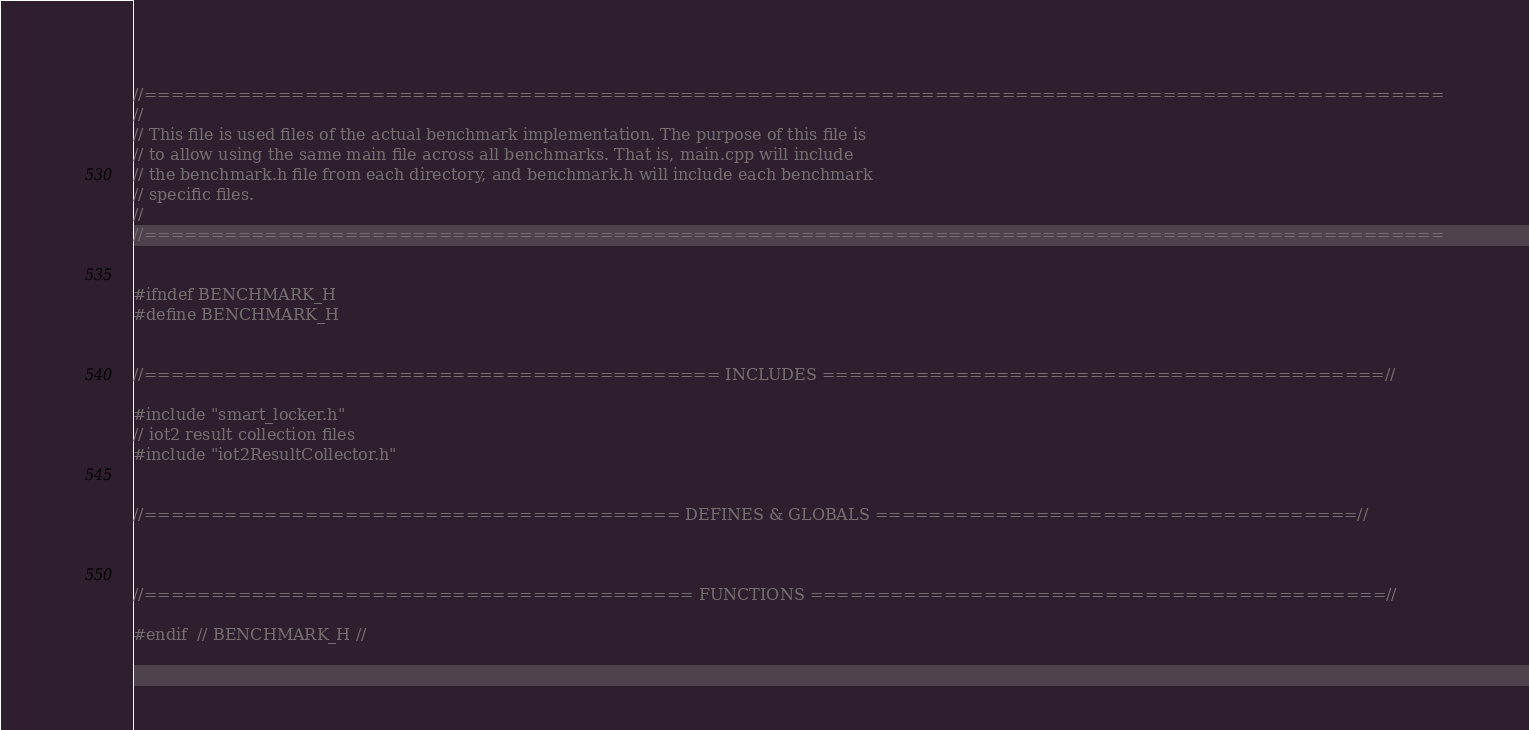<code> <loc_0><loc_0><loc_500><loc_500><_C_>//=================================================================================================
//
// This file is used files of the actual benchmark implementation. The purpose of this file is
// to allow using the same main file across all benchmarks. That is, main.cpp will include
// the benchmark.h file from each directory, and benchmark.h will include each benchmark
// specific files.
//
//=================================================================================================


#ifndef BENCHMARK_H
#define BENCHMARK_H


//=========================================== INCLUDES ==========================================//

#include "smart_locker.h"
// iot2 result collection files
#include "iot2ResultCollector.h"


//======================================== DEFINES & GLOBALS ====================================//



//========================================= FUNCTIONS ===========================================//

#endif  // BENCHMARK_H //</code> 